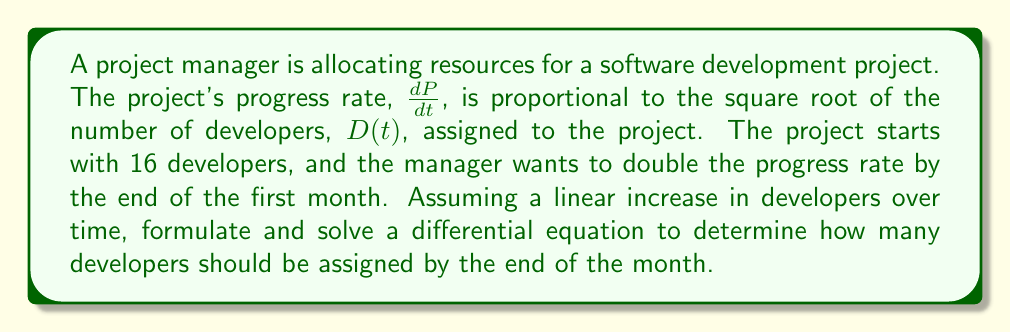Help me with this question. 1. Let's formulate the differential equation:
   $$\frac{dP}{dt} = k\sqrt{D(t)}$$
   where $k$ is a constant of proportionality.

2. Initially, with 16 developers:
   $$\frac{dP}{dt}(0) = k\sqrt{16} = 4k$$

3. We want to double the progress rate by the end of the month, so:
   $$\frac{dP}{dt}(1) = 2 \cdot \frac{dP}{dt}(0) = 8k$$

4. This means:
   $$8k = k\sqrt{D(1)}$$
   $$64 = D(1)$$

5. Assuming a linear increase in developers:
   $$D(t) = 16 + 48t$$

6. Substituting this into our original equation:
   $$\frac{dP}{dt} = k\sqrt{16 + 48t}$$

7. To solve for $k$, we can use the initial condition:
   $$4k = k\sqrt{16}$$
   $$k = 1$$

8. Our final differential equation is:
   $$\frac{dP}{dt} = \sqrt{16 + 48t}$$

9. To find $P(t)$, we integrate both sides:
   $$P(t) = \int_0^t \sqrt{16 + 48s} ds$$

10. This integral can be solved using substitution:
    $$P(t) = \frac{1}{72}(16 + 48t)^{3/2} - \frac{64}{72} + C$$

11. Using $P(0) = 0$, we can find $C = \frac{64}{72}$

12. The final solution is:
    $$P(t) = \frac{1}{72}(16 + 48t)^{3/2} - \frac{64}{72}$$
Answer: 64 developers 